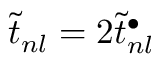<formula> <loc_0><loc_0><loc_500><loc_500>{ \widetilde { t } _ { n l } = 2 \widetilde { t } _ { n l } ^ { \bullet } }</formula> 